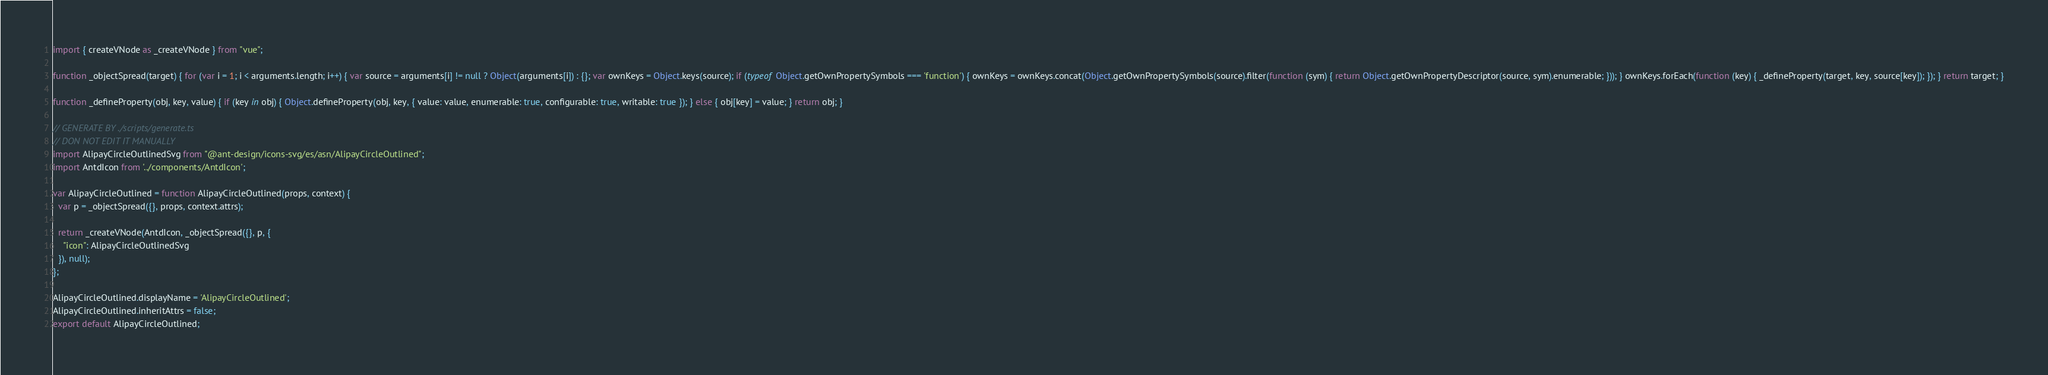<code> <loc_0><loc_0><loc_500><loc_500><_JavaScript_>import { createVNode as _createVNode } from "vue";

function _objectSpread(target) { for (var i = 1; i < arguments.length; i++) { var source = arguments[i] != null ? Object(arguments[i]) : {}; var ownKeys = Object.keys(source); if (typeof Object.getOwnPropertySymbols === 'function') { ownKeys = ownKeys.concat(Object.getOwnPropertySymbols(source).filter(function (sym) { return Object.getOwnPropertyDescriptor(source, sym).enumerable; })); } ownKeys.forEach(function (key) { _defineProperty(target, key, source[key]); }); } return target; }

function _defineProperty(obj, key, value) { if (key in obj) { Object.defineProperty(obj, key, { value: value, enumerable: true, configurable: true, writable: true }); } else { obj[key] = value; } return obj; }

// GENERATE BY ./scripts/generate.ts
// DON NOT EDIT IT MANUALLY
import AlipayCircleOutlinedSvg from "@ant-design/icons-svg/es/asn/AlipayCircleOutlined";
import AntdIcon from '../components/AntdIcon';

var AlipayCircleOutlined = function AlipayCircleOutlined(props, context) {
  var p = _objectSpread({}, props, context.attrs);

  return _createVNode(AntdIcon, _objectSpread({}, p, {
    "icon": AlipayCircleOutlinedSvg
  }), null);
};

AlipayCircleOutlined.displayName = 'AlipayCircleOutlined';
AlipayCircleOutlined.inheritAttrs = false;
export default AlipayCircleOutlined;</code> 